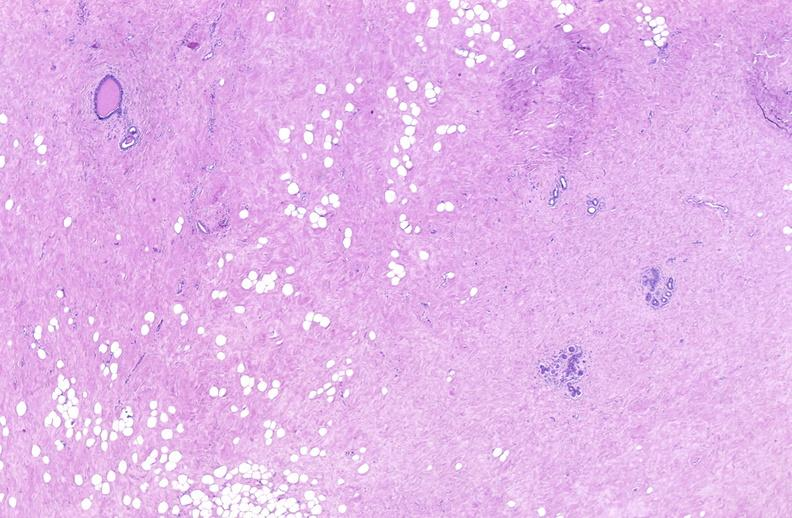does anencephaly show breast, fibroadenoma?
Answer the question using a single word or phrase. No 